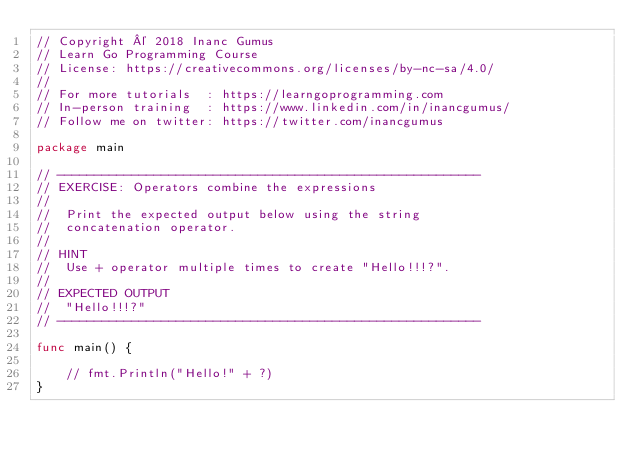Convert code to text. <code><loc_0><loc_0><loc_500><loc_500><_Go_>// Copyright © 2018 Inanc Gumus
// Learn Go Programming Course
// License: https://creativecommons.org/licenses/by-nc-sa/4.0/
//
// For more tutorials  : https://learngoprogramming.com
// In-person training  : https://www.linkedin.com/in/inancgumus/
// Follow me on twitter: https://twitter.com/inancgumus

package main

// ---------------------------------------------------------
// EXERCISE: Operators combine the expressions
//
//  Print the expected output below using the string
//  concatenation operator.
//
// HINT
//  Use + operator multiple times to create "Hello!!!?".
//
// EXPECTED OUTPUT
//  "Hello!!!?"
// ---------------------------------------------------------

func main() {

	// fmt.Println("Hello!" + ?)
}
</code> 